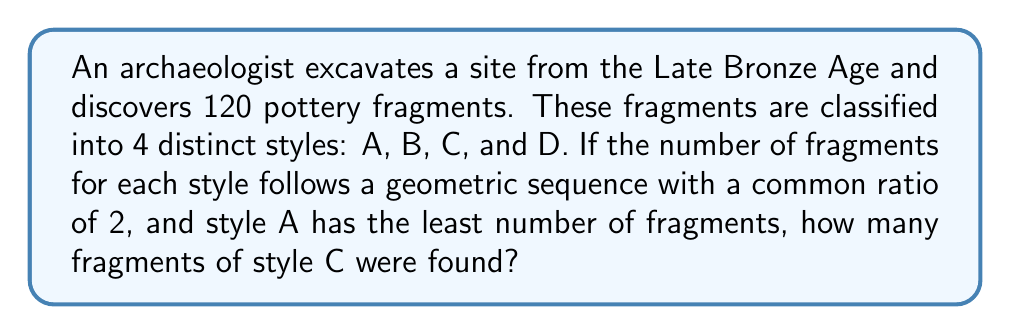Solve this math problem. Let's approach this step-by-step:

1) We know that the number of fragments for each style follows a geometric sequence with a common ratio of 2. Let's denote the number of fragments of style A (the least) as $x$.

2) Then, the sequence would be:
   Style A: $x$
   Style B: $2x$
   Style C: $4x$
   Style D: $8x$

3) The total number of fragments is 120. We can set up an equation:

   $$x + 2x + 4x + 8x = 120$$

4) Simplify the left side of the equation:

   $$15x = 120$$

5) Solve for $x$:

   $$x = \frac{120}{15} = 8$$

6) Now that we know $x = 8$, we can determine the number of fragments for each style:
   Style A: $8$
   Style B: $16$
   Style C: $32$
   Style D: $64$

7) The question asks for the number of fragments of style C, which is $4x = 4(8) = 32$.
Answer: 32 